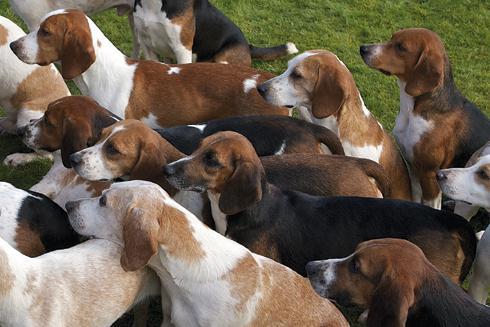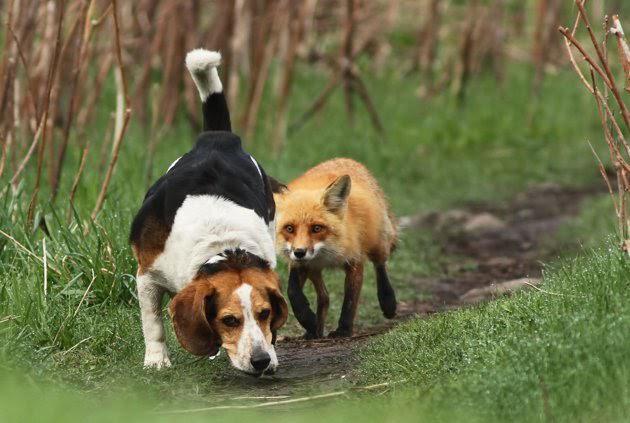The first image is the image on the left, the second image is the image on the right. Evaluate the accuracy of this statement regarding the images: "Right image shows a pack of dogs running forward.". Is it true? Answer yes or no. No. The first image is the image on the left, the second image is the image on the right. Evaluate the accuracy of this statement regarding the images: "Dogs are running in both pictures.". Is it true? Answer yes or no. No. 